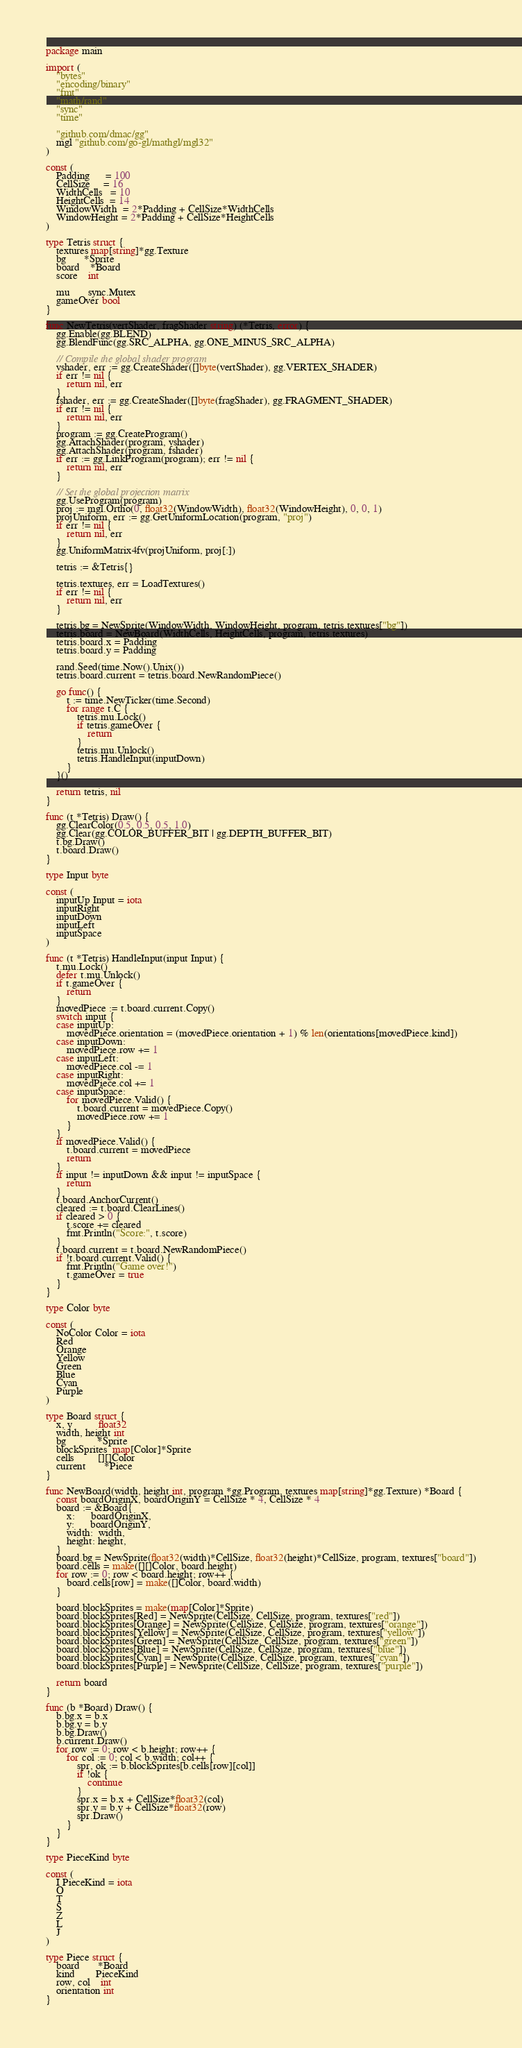Convert code to text. <code><loc_0><loc_0><loc_500><loc_500><_Go_>package main

import (
	"bytes"
	"encoding/binary"
	"fmt"
	"math/rand"
	"sync"
	"time"

	"github.com/dmac/gg"
	mgl "github.com/go-gl/mathgl/mgl32"
)

const (
	Padding      = 100
	CellSize     = 16
	WidthCells   = 10
	HeightCells  = 14
	WindowWidth  = 2*Padding + CellSize*WidthCells
	WindowHeight = 2*Padding + CellSize*HeightCells
)

type Tetris struct {
	textures map[string]*gg.Texture
	bg       *Sprite
	board    *Board
	score    int

	mu       sync.Mutex
	gameOver bool
}

func NewTetris(vertShader, fragShader string) (*Tetris, error) {
	gg.Enable(gg.BLEND)
	gg.BlendFunc(gg.SRC_ALPHA, gg.ONE_MINUS_SRC_ALPHA)

	// Compile the global shader program
	vshader, err := gg.CreateShader([]byte(vertShader), gg.VERTEX_SHADER)
	if err != nil {
		return nil, err
	}
	fshader, err := gg.CreateShader([]byte(fragShader), gg.FRAGMENT_SHADER)
	if err != nil {
		return nil, err
	}
	program := gg.CreateProgram()
	gg.AttachShader(program, vshader)
	gg.AttachShader(program, fshader)
	if err := gg.LinkProgram(program); err != nil {
		return nil, err
	}

	// Set the global projection matrix
	gg.UseProgram(program)
	proj := mgl.Ortho(0, float32(WindowWidth), float32(WindowHeight), 0, 0, 1)
	projUniform, err := gg.GetUniformLocation(program, "proj")
	if err != nil {
		return nil, err
	}
	gg.UniformMatrix4fv(projUniform, proj[:])

	tetris := &Tetris{}

	tetris.textures, err = LoadTextures()
	if err != nil {
		return nil, err
	}

	tetris.bg = NewSprite(WindowWidth, WindowHeight, program, tetris.textures["bg"])
	tetris.board = NewBoard(WidthCells, HeightCells, program, tetris.textures)
	tetris.board.x = Padding
	tetris.board.y = Padding

	rand.Seed(time.Now().Unix())
	tetris.board.current = tetris.board.NewRandomPiece()

	go func() {
		t := time.NewTicker(time.Second)
		for range t.C {
			tetris.mu.Lock()
			if tetris.gameOver {
				return
			}
			tetris.mu.Unlock()
			tetris.HandleInput(inputDown)
		}
	}()

	return tetris, nil
}

func (t *Tetris) Draw() {
	gg.ClearColor(0.5, 0.5, 0.5, 1.0)
	gg.Clear(gg.COLOR_BUFFER_BIT | gg.DEPTH_BUFFER_BIT)
	t.bg.Draw()
	t.board.Draw()
}

type Input byte

const (
	inputUp Input = iota
	inputRight
	inputDown
	inputLeft
	inputSpace
)

func (t *Tetris) HandleInput(input Input) {
	t.mu.Lock()
	defer t.mu.Unlock()
	if t.gameOver {
		return
	}
	movedPiece := t.board.current.Copy()
	switch input {
	case inputUp:
		movedPiece.orientation = (movedPiece.orientation + 1) % len(orientations[movedPiece.kind])
	case inputDown:
		movedPiece.row += 1
	case inputLeft:
		movedPiece.col -= 1
	case inputRight:
		movedPiece.col += 1
	case inputSpace:
		for movedPiece.Valid() {
			t.board.current = movedPiece.Copy()
			movedPiece.row += 1
		}
	}
	if movedPiece.Valid() {
		t.board.current = movedPiece
		return
	}
	if input != inputDown && input != inputSpace {
		return
	}
	t.board.AnchorCurrent()
	cleared := t.board.ClearLines()
	if cleared > 0 {
		t.score += cleared
		fmt.Println("Score:", t.score)
	}
	t.board.current = t.board.NewRandomPiece()
	if !t.board.current.Valid() {
		fmt.Println("Game over!")
		t.gameOver = true
	}
}

type Color byte

const (
	NoColor Color = iota
	Red
	Orange
	Yellow
	Green
	Blue
	Cyan
	Purple
)

type Board struct {
	x, y          float32
	width, height int
	bg            *Sprite
	blockSprites  map[Color]*Sprite
	cells         [][]Color
	current       *Piece
}

func NewBoard(width, height int, program *gg.Program, textures map[string]*gg.Texture) *Board {
	const boardOriginX, boardOriginY = CellSize * 4, CellSize * 4
	board := &Board{
		x:      boardOriginX,
		y:      boardOriginY,
		width:  width,
		height: height,
	}
	board.bg = NewSprite(float32(width)*CellSize, float32(height)*CellSize, program, textures["board"])
	board.cells = make([][]Color, board.height)
	for row := 0; row < board.height; row++ {
		board.cells[row] = make([]Color, board.width)
	}

	board.blockSprites = make(map[Color]*Sprite)
	board.blockSprites[Red] = NewSprite(CellSize, CellSize, program, textures["red"])
	board.blockSprites[Orange] = NewSprite(CellSize, CellSize, program, textures["orange"])
	board.blockSprites[Yellow] = NewSprite(CellSize, CellSize, program, textures["yellow"])
	board.blockSprites[Green] = NewSprite(CellSize, CellSize, program, textures["green"])
	board.blockSprites[Blue] = NewSprite(CellSize, CellSize, program, textures["blue"])
	board.blockSprites[Cyan] = NewSprite(CellSize, CellSize, program, textures["cyan"])
	board.blockSprites[Purple] = NewSprite(CellSize, CellSize, program, textures["purple"])

	return board
}

func (b *Board) Draw() {
	b.bg.x = b.x
	b.bg.y = b.y
	b.bg.Draw()
	b.current.Draw()
	for row := 0; row < b.height; row++ {
		for col := 0; col < b.width; col++ {
			spr, ok := b.blockSprites[b.cells[row][col]]
			if !ok {
				continue
			}
			spr.x = b.x + CellSize*float32(col)
			spr.y = b.y + CellSize*float32(row)
			spr.Draw()
		}
	}
}

type PieceKind byte

const (
	I PieceKind = iota
	O
	T
	S
	Z
	L
	J
)

type Piece struct {
	board       *Board
	kind        PieceKind
	row, col    int
	orientation int
}
</code> 